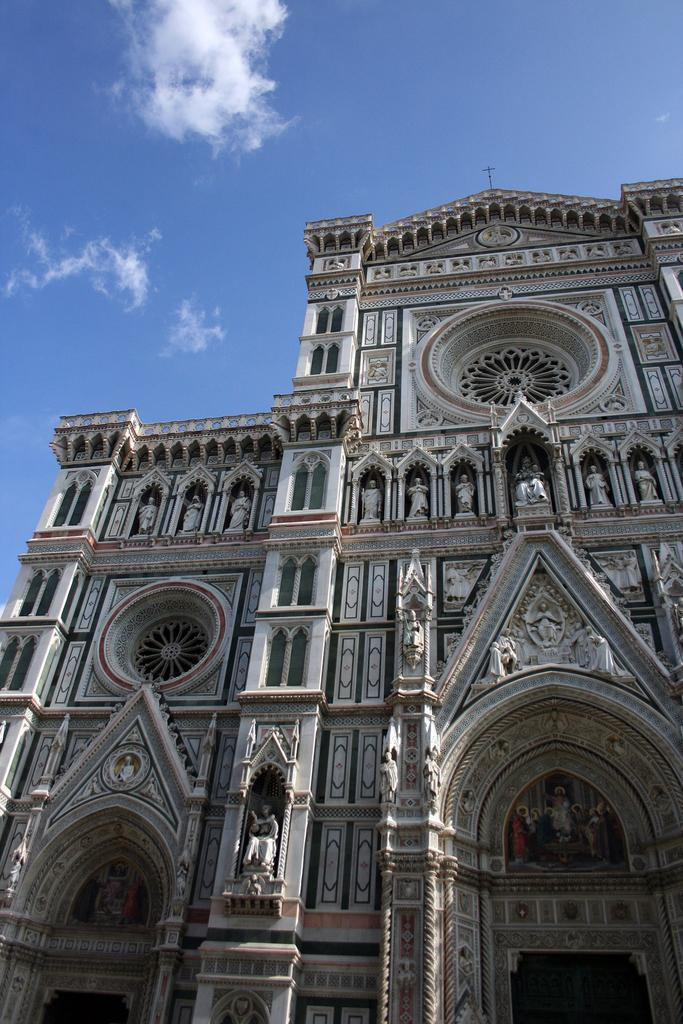What type of structures can be seen in the image? There are buildings in the image. What decorative features are present on the buildings? There are carvings on the buildings. What additional objects can be seen in the image? There are statues in the image. How would you describe the sky in the image? The sky is blue and cloudy in the image. What type of copper range can be seen in the image? There is no copper range present in the image. What disease is depicted in the carvings on the buildings? The carvings on the buildings do not depict any diseases; they are decorative features. 